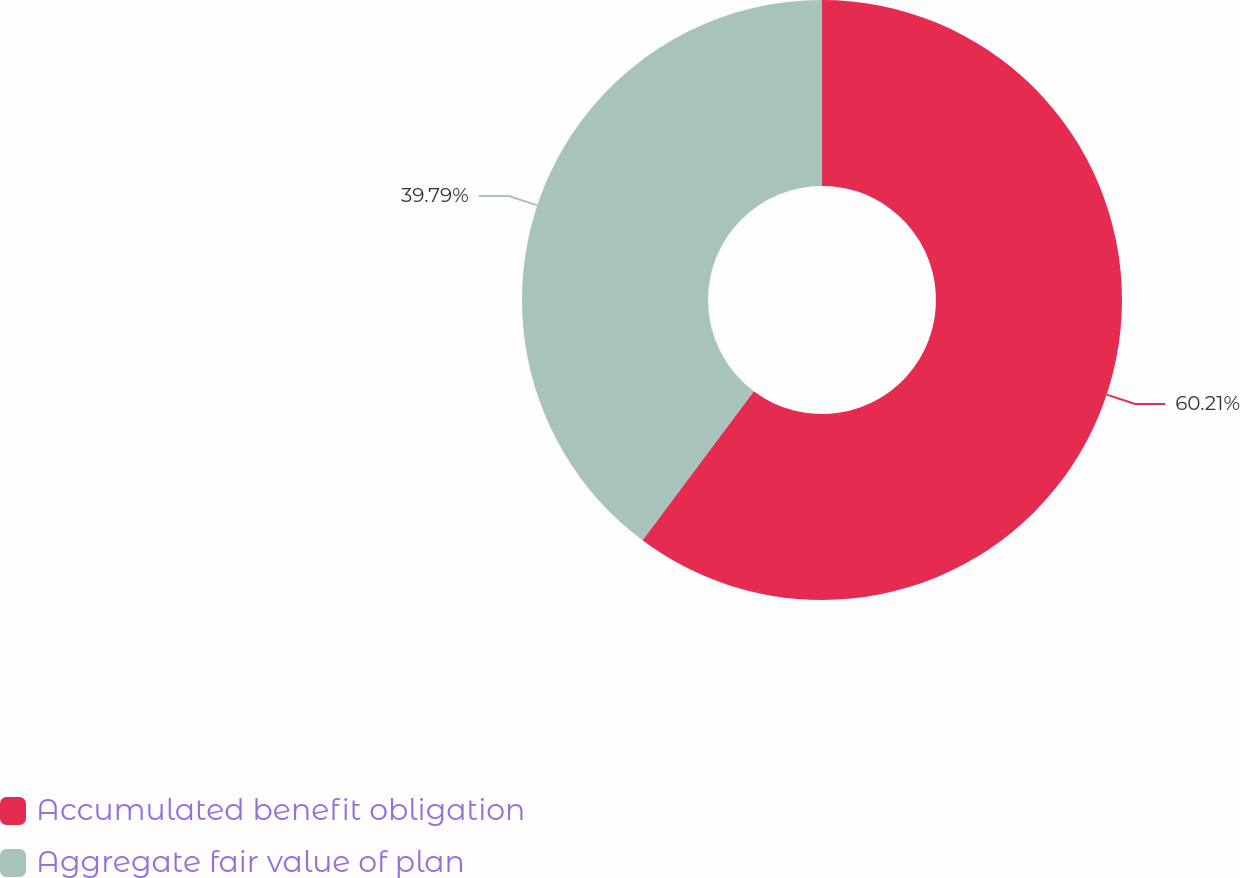Convert chart to OTSL. <chart><loc_0><loc_0><loc_500><loc_500><pie_chart><fcel>Accumulated benefit obligation<fcel>Aggregate fair value of plan<nl><fcel>60.21%<fcel>39.79%<nl></chart> 